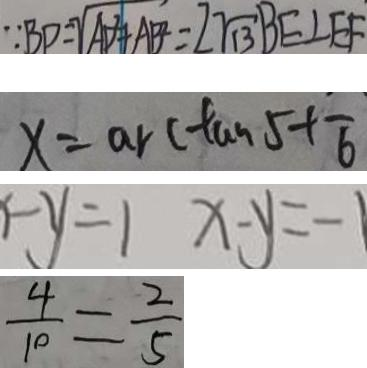Convert formula to latex. <formula><loc_0><loc_0><loc_500><loc_500>\because B P = \sqrt { A B + A B } = 2 \sqrt { 1 3 } B E \bot E F 
 x = \arctan 5 + \overline { 6 } 
 - y = 1 x - y = - 1 
 \frac { 4 } { 1 0 } = \frac { 2 } { 5 }</formula> 